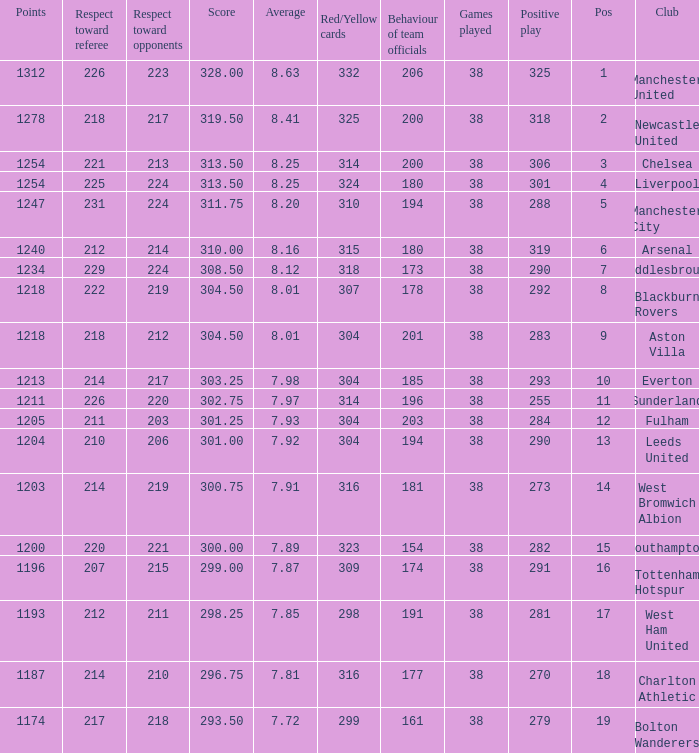Name the most red/yellow cards for positive play being 255 314.0. 